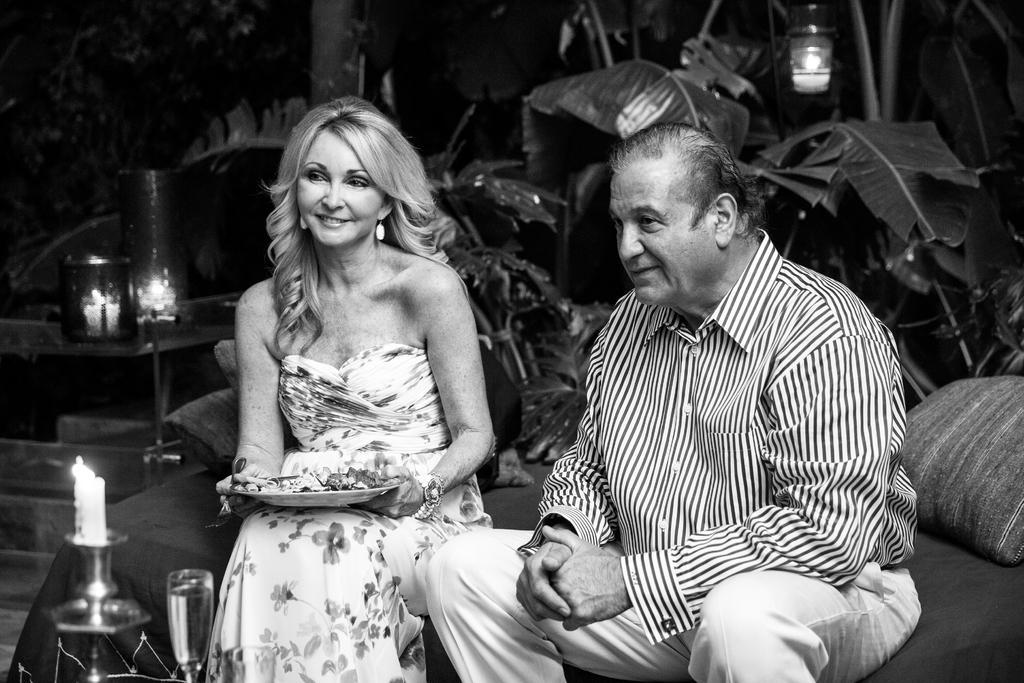In one or two sentences, can you explain what this image depicts? In the picture I can see two persons. There is a man on the right side is wearing a shirt and there is a smile on his face. I can see the pillows on the sofa. There is a woman on the left side is holding a plate in her hands and she is smiling as well. I can see the candles in a glass box on the left side. I can see the candles and a glass on the bottom left side. In the background, I can see the plants. 